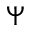<formula> <loc_0><loc_0><loc_500><loc_500>\Psi</formula> 